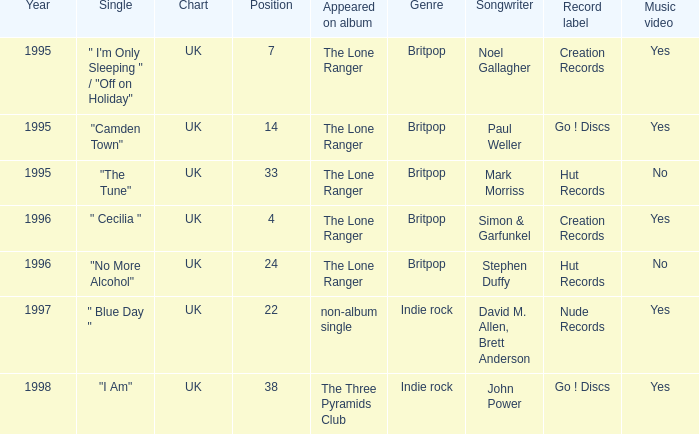When the position is less than 7, what is the appeared on album? The Lone Ranger. 